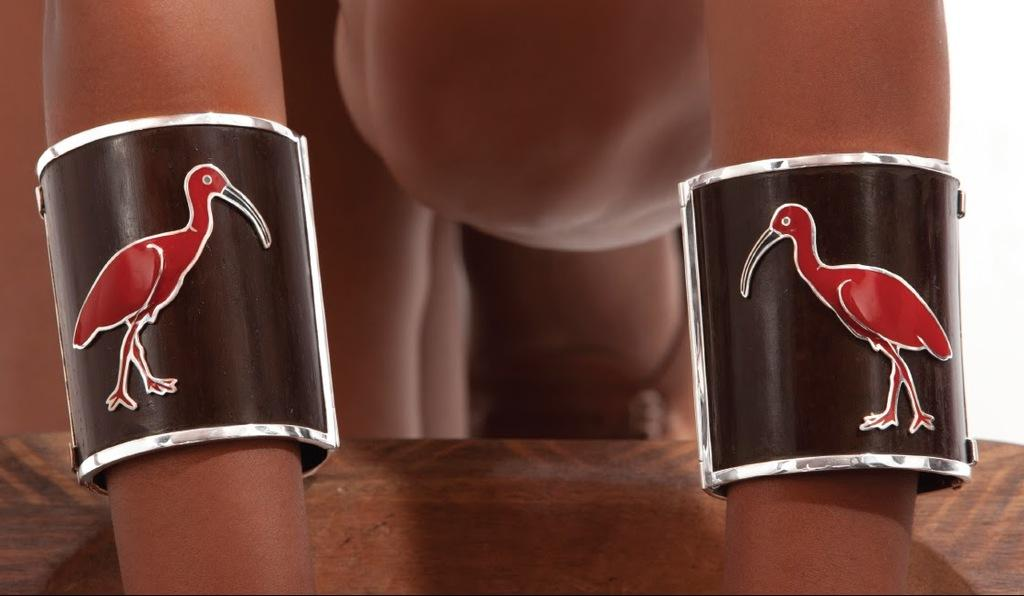What is the main subject of the image? There is a person in the image. Can you describe any accessories the person is wearing? The person is wearing bracelets on their hands. What type of protest is the person participating in within the image? There is no protest present in the image; it only features a person wearing bracelets on their hands. 